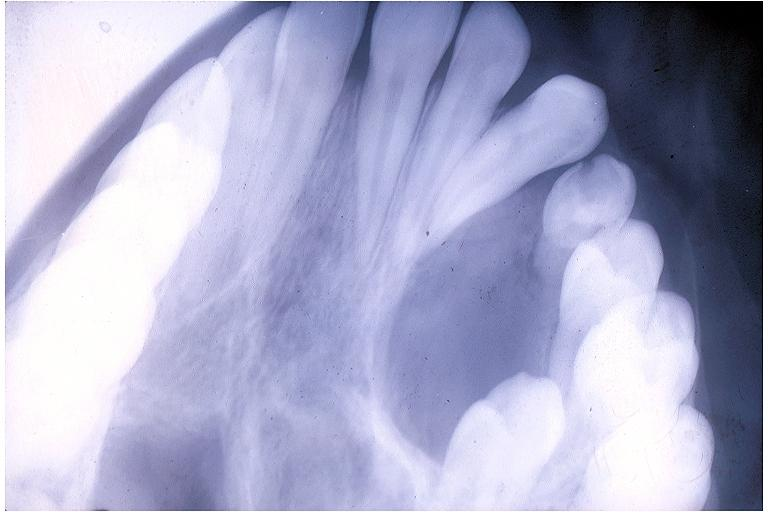where is this?
Answer the question using a single word or phrase. Oral 